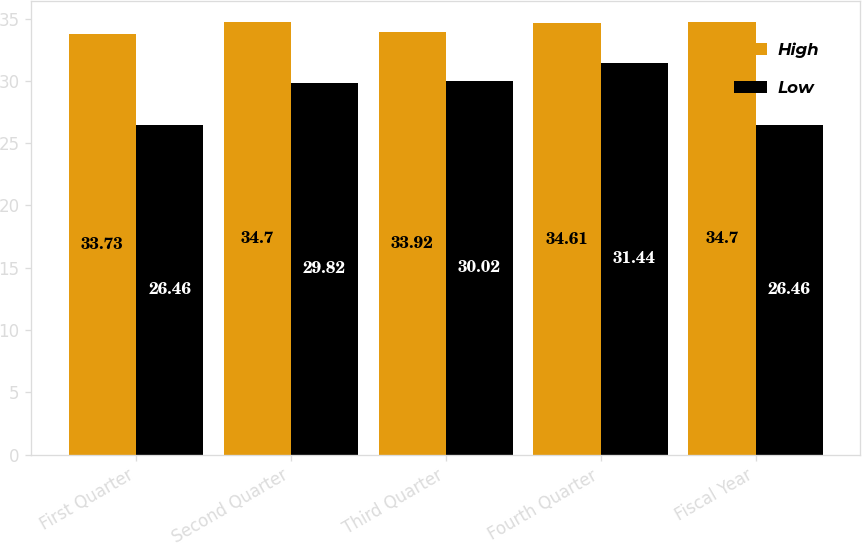Convert chart. <chart><loc_0><loc_0><loc_500><loc_500><stacked_bar_chart><ecel><fcel>First Quarter<fcel>Second Quarter<fcel>Third Quarter<fcel>Fourth Quarter<fcel>Fiscal Year<nl><fcel>High<fcel>33.73<fcel>34.7<fcel>33.92<fcel>34.61<fcel>34.7<nl><fcel>Low<fcel>26.46<fcel>29.82<fcel>30.02<fcel>31.44<fcel>26.46<nl></chart> 